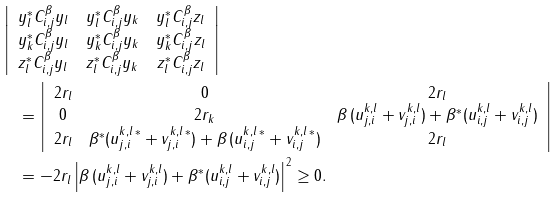<formula> <loc_0><loc_0><loc_500><loc_500>& \left | \begin{array} { c c c } y _ { l } ^ { \ast } C _ { i , j } ^ { \beta } y _ { l } & y _ { l } ^ { \ast } C _ { i , j } ^ { \beta } y _ { k } & y _ { l } ^ { \ast } C _ { i , j } ^ { \beta } z _ { l } \\ y _ { k } ^ { \ast } C _ { i , j } ^ { \beta } y _ { l } & y _ { k } ^ { \ast } C _ { i , j } ^ { \beta } y _ { k } & y _ { k } ^ { \ast } C _ { i , j } ^ { \beta } z _ { l } \\ z _ { l } ^ { \ast } C _ { i , j } ^ { \beta } y _ { l } & z _ { l } ^ { \ast } C _ { i , j } ^ { \beta } y _ { k } & z _ { l } ^ { \ast } C _ { i , j } ^ { \beta } z _ { l } \end{array} \right | \\ & \quad = \left | \begin{array} { c c c } 2 r _ { l } & 0 & 2 r _ { l } \\ 0 & 2 r _ { k } & \beta \, ( u _ { j , i } ^ { k , l } + v _ { j , i } ^ { k , l } ) + \beta ^ { * } ( u _ { i , j } ^ { k , l } + v _ { i , j } ^ { k , l } ) \\ 2 r _ { l } & \beta ^ { * } ( u _ { j , i } ^ { k , l \, * } + v _ { j , i } ^ { k , l \, * } ) + \beta \, ( u _ { i , j } ^ { k , l \, * } + v _ { i , j } ^ { k , l \, * } ) & 2 r _ { l } \end{array} \right | \\ & \quad = - 2 r _ { l } \left | \beta \, ( u _ { j , i } ^ { k , l } + v _ { j , i } ^ { k , l } ) + \beta ^ { * } ( u _ { i , j } ^ { k , l } + v _ { i , j } ^ { k , l } ) \right | ^ { 2 } \geq 0 .</formula> 